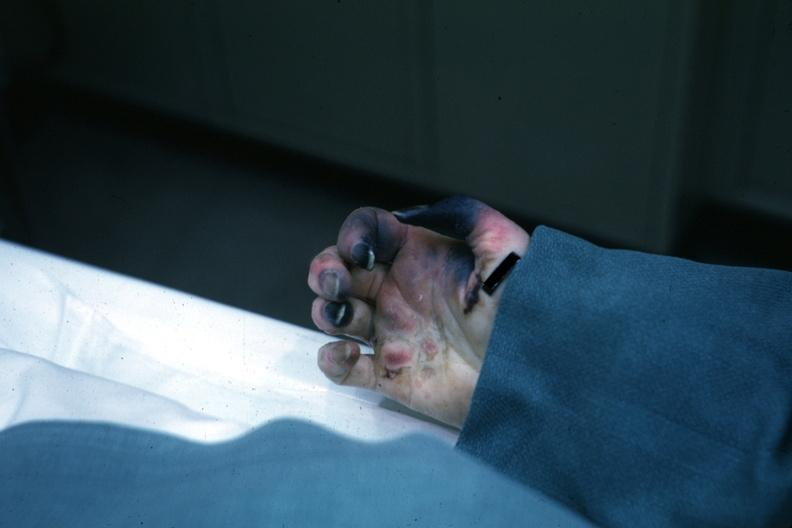re cells present?
Answer the question using a single word or phrase. No 